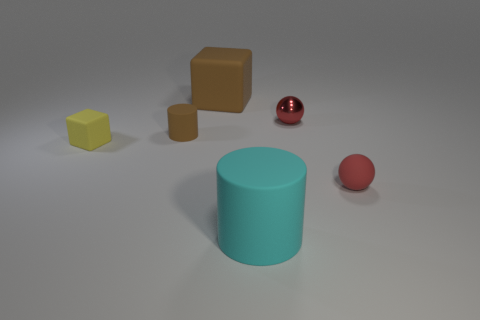Add 2 big brown objects. How many objects exist? 8 Subtract all yellow cubes. How many cubes are left? 1 Subtract all cyan cubes. How many brown spheres are left? 0 Subtract all tiny matte cylinders. Subtract all cyan metallic balls. How many objects are left? 5 Add 1 large blocks. How many large blocks are left? 2 Add 6 large cyan metallic cubes. How many large cyan metallic cubes exist? 6 Subtract 0 yellow cylinders. How many objects are left? 6 Subtract all cubes. How many objects are left? 4 Subtract 1 spheres. How many spheres are left? 1 Subtract all red blocks. Subtract all purple spheres. How many blocks are left? 2 